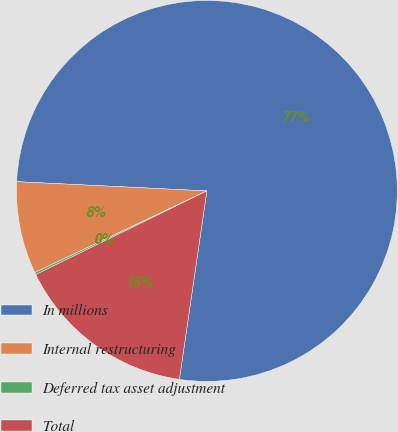Convert chart to OTSL. <chart><loc_0><loc_0><loc_500><loc_500><pie_chart><fcel>In millions<fcel>Internal restructuring<fcel>Deferred tax asset adjustment<fcel>Total<nl><fcel>76.53%<fcel>7.82%<fcel>0.19%<fcel>15.46%<nl></chart> 